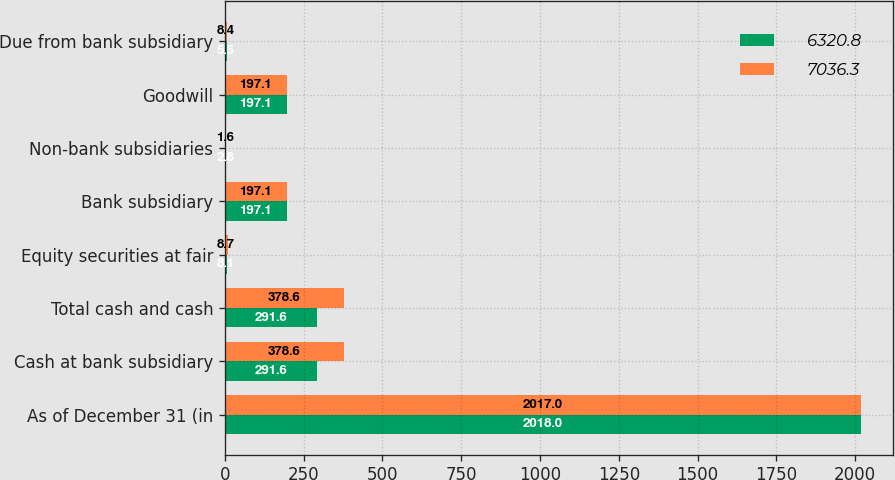<chart> <loc_0><loc_0><loc_500><loc_500><stacked_bar_chart><ecel><fcel>As of December 31 (in<fcel>Cash at bank subsidiary<fcel>Total cash and cash<fcel>Equity securities at fair<fcel>Bank subsidiary<fcel>Non-bank subsidiaries<fcel>Goodwill<fcel>Due from bank subsidiary<nl><fcel>6320.8<fcel>2018<fcel>291.6<fcel>291.6<fcel>8.1<fcel>197.1<fcel>2.8<fcel>197.1<fcel>5.5<nl><fcel>7036.3<fcel>2017<fcel>378.6<fcel>378.6<fcel>8.7<fcel>197.1<fcel>1.6<fcel>197.1<fcel>8.4<nl></chart> 